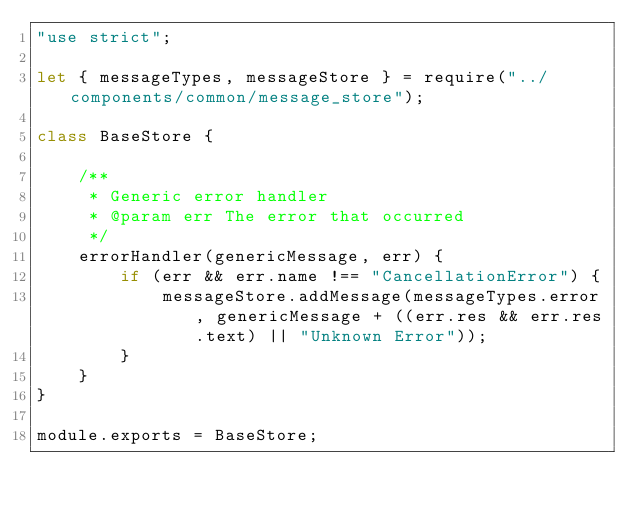Convert code to text. <code><loc_0><loc_0><loc_500><loc_500><_JavaScript_>"use strict";

let { messageTypes, messageStore } = require("../components/common/message_store");

class BaseStore {

    /**
     * Generic error handler
     * @param err The error that occurred
     */
    errorHandler(genericMessage, err) {
        if (err && err.name !== "CancellationError") {
            messageStore.addMessage(messageTypes.error, genericMessage + ((err.res && err.res.text) || "Unknown Error"));
        }
    }
}

module.exports = BaseStore;
</code> 